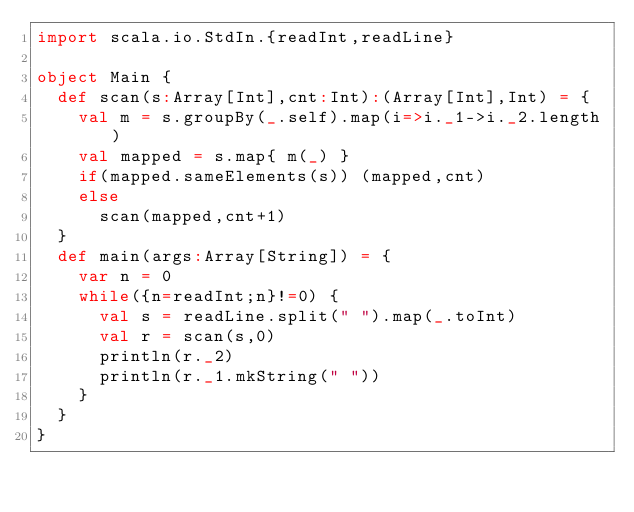Convert code to text. <code><loc_0><loc_0><loc_500><loc_500><_Scala_>import scala.io.StdIn.{readInt,readLine}

object Main {
  def scan(s:Array[Int],cnt:Int):(Array[Int],Int) = {
    val m = s.groupBy(_.self).map(i=>i._1->i._2.length)
    val mapped = s.map{ m(_) }
    if(mapped.sameElements(s)) (mapped,cnt)
    else
      scan(mapped,cnt+1)
  }
  def main(args:Array[String]) = {
    var n = 0
    while({n=readInt;n}!=0) {
      val s = readLine.split(" ").map(_.toInt)
      val r = scan(s,0)
      println(r._2)
      println(r._1.mkString(" "))
    }
  }
}</code> 